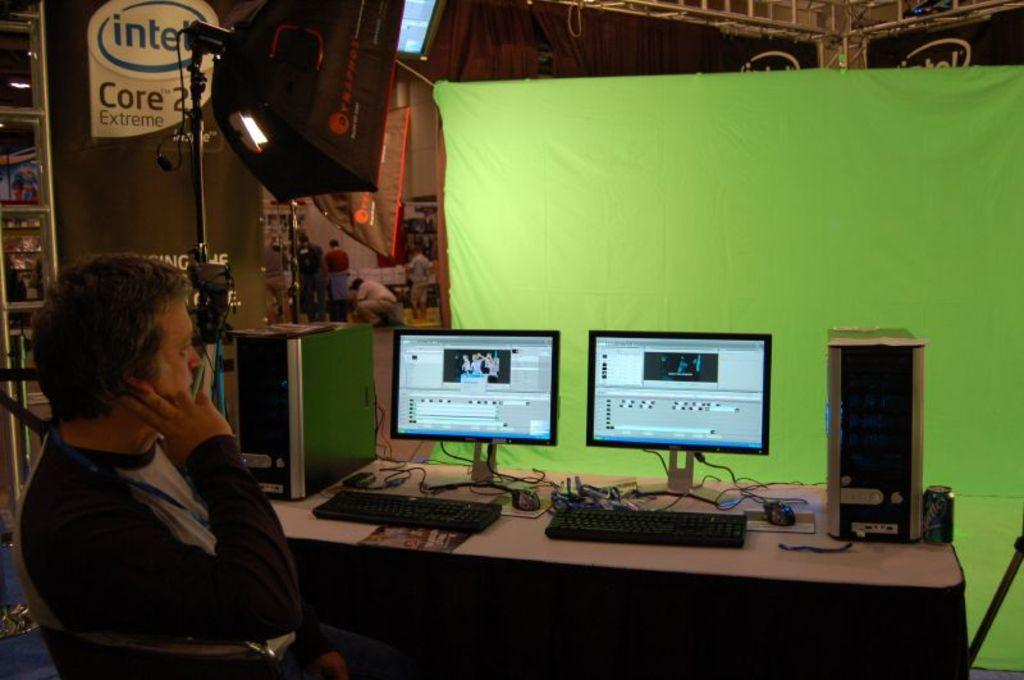<image>
Present a compact description of the photo's key features. a man sitting in front of two computer screens  an in front of a sign that says 'intel core 2 extreme' on it 